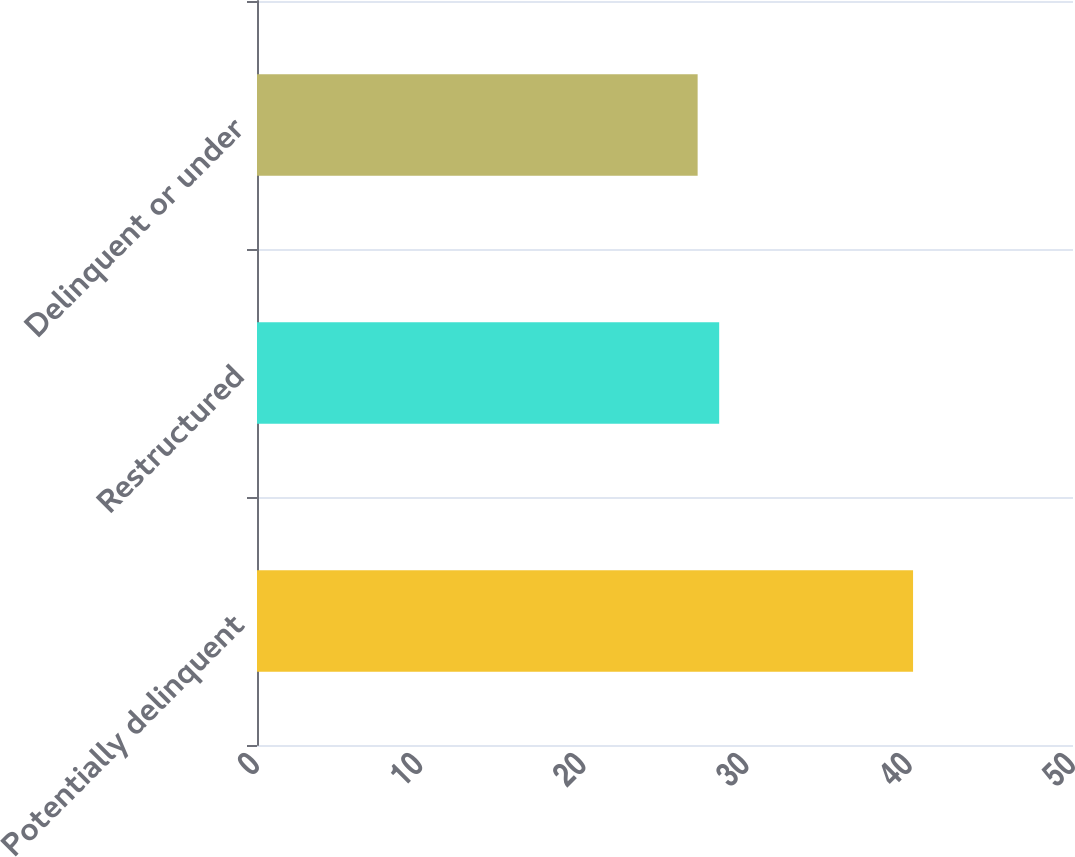Convert chart to OTSL. <chart><loc_0><loc_0><loc_500><loc_500><bar_chart><fcel>Potentially delinquent<fcel>Restructured<fcel>Delinquent or under<nl><fcel>40.2<fcel>28.32<fcel>27<nl></chart> 